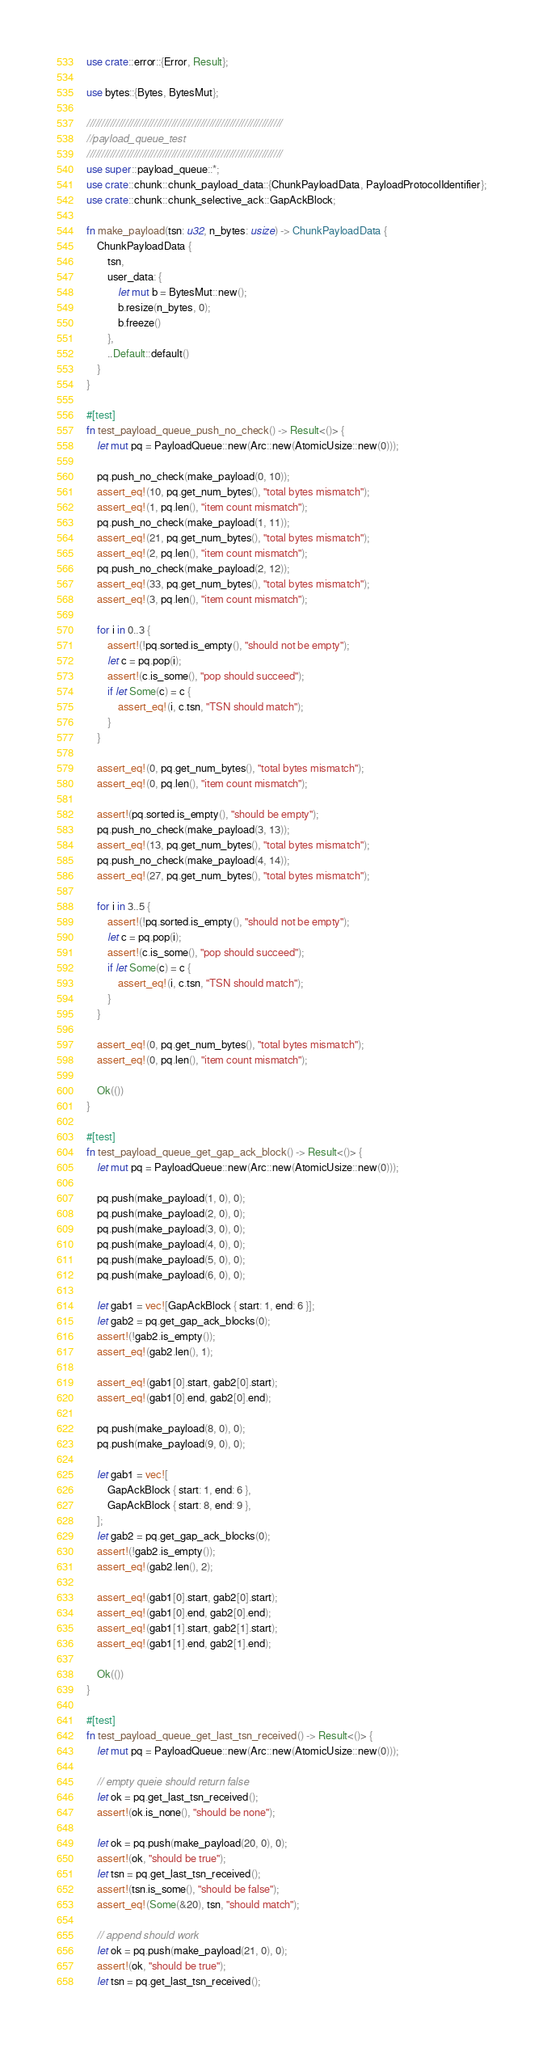<code> <loc_0><loc_0><loc_500><loc_500><_Rust_>use crate::error::{Error, Result};

use bytes::{Bytes, BytesMut};

///////////////////////////////////////////////////////////////////
//payload_queue_test
///////////////////////////////////////////////////////////////////
use super::payload_queue::*;
use crate::chunk::chunk_payload_data::{ChunkPayloadData, PayloadProtocolIdentifier};
use crate::chunk::chunk_selective_ack::GapAckBlock;

fn make_payload(tsn: u32, n_bytes: usize) -> ChunkPayloadData {
    ChunkPayloadData {
        tsn,
        user_data: {
            let mut b = BytesMut::new();
            b.resize(n_bytes, 0);
            b.freeze()
        },
        ..Default::default()
    }
}

#[test]
fn test_payload_queue_push_no_check() -> Result<()> {
    let mut pq = PayloadQueue::new(Arc::new(AtomicUsize::new(0)));

    pq.push_no_check(make_payload(0, 10));
    assert_eq!(10, pq.get_num_bytes(), "total bytes mismatch");
    assert_eq!(1, pq.len(), "item count mismatch");
    pq.push_no_check(make_payload(1, 11));
    assert_eq!(21, pq.get_num_bytes(), "total bytes mismatch");
    assert_eq!(2, pq.len(), "item count mismatch");
    pq.push_no_check(make_payload(2, 12));
    assert_eq!(33, pq.get_num_bytes(), "total bytes mismatch");
    assert_eq!(3, pq.len(), "item count mismatch");

    for i in 0..3 {
        assert!(!pq.sorted.is_empty(), "should not be empty");
        let c = pq.pop(i);
        assert!(c.is_some(), "pop should succeed");
        if let Some(c) = c {
            assert_eq!(i, c.tsn, "TSN should match");
        }
    }

    assert_eq!(0, pq.get_num_bytes(), "total bytes mismatch");
    assert_eq!(0, pq.len(), "item count mismatch");

    assert!(pq.sorted.is_empty(), "should be empty");
    pq.push_no_check(make_payload(3, 13));
    assert_eq!(13, pq.get_num_bytes(), "total bytes mismatch");
    pq.push_no_check(make_payload(4, 14));
    assert_eq!(27, pq.get_num_bytes(), "total bytes mismatch");

    for i in 3..5 {
        assert!(!pq.sorted.is_empty(), "should not be empty");
        let c = pq.pop(i);
        assert!(c.is_some(), "pop should succeed");
        if let Some(c) = c {
            assert_eq!(i, c.tsn, "TSN should match");
        }
    }

    assert_eq!(0, pq.get_num_bytes(), "total bytes mismatch");
    assert_eq!(0, pq.len(), "item count mismatch");

    Ok(())
}

#[test]
fn test_payload_queue_get_gap_ack_block() -> Result<()> {
    let mut pq = PayloadQueue::new(Arc::new(AtomicUsize::new(0)));

    pq.push(make_payload(1, 0), 0);
    pq.push(make_payload(2, 0), 0);
    pq.push(make_payload(3, 0), 0);
    pq.push(make_payload(4, 0), 0);
    pq.push(make_payload(5, 0), 0);
    pq.push(make_payload(6, 0), 0);

    let gab1 = vec![GapAckBlock { start: 1, end: 6 }];
    let gab2 = pq.get_gap_ack_blocks(0);
    assert!(!gab2.is_empty());
    assert_eq!(gab2.len(), 1);

    assert_eq!(gab1[0].start, gab2[0].start);
    assert_eq!(gab1[0].end, gab2[0].end);

    pq.push(make_payload(8, 0), 0);
    pq.push(make_payload(9, 0), 0);

    let gab1 = vec![
        GapAckBlock { start: 1, end: 6 },
        GapAckBlock { start: 8, end: 9 },
    ];
    let gab2 = pq.get_gap_ack_blocks(0);
    assert!(!gab2.is_empty());
    assert_eq!(gab2.len(), 2);

    assert_eq!(gab1[0].start, gab2[0].start);
    assert_eq!(gab1[0].end, gab2[0].end);
    assert_eq!(gab1[1].start, gab2[1].start);
    assert_eq!(gab1[1].end, gab2[1].end);

    Ok(())
}

#[test]
fn test_payload_queue_get_last_tsn_received() -> Result<()> {
    let mut pq = PayloadQueue::new(Arc::new(AtomicUsize::new(0)));

    // empty queie should return false
    let ok = pq.get_last_tsn_received();
    assert!(ok.is_none(), "should be none");

    let ok = pq.push(make_payload(20, 0), 0);
    assert!(ok, "should be true");
    let tsn = pq.get_last_tsn_received();
    assert!(tsn.is_some(), "should be false");
    assert_eq!(Some(&20), tsn, "should match");

    // append should work
    let ok = pq.push(make_payload(21, 0), 0);
    assert!(ok, "should be true");
    let tsn = pq.get_last_tsn_received();</code> 